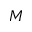<formula> <loc_0><loc_0><loc_500><loc_500>M</formula> 